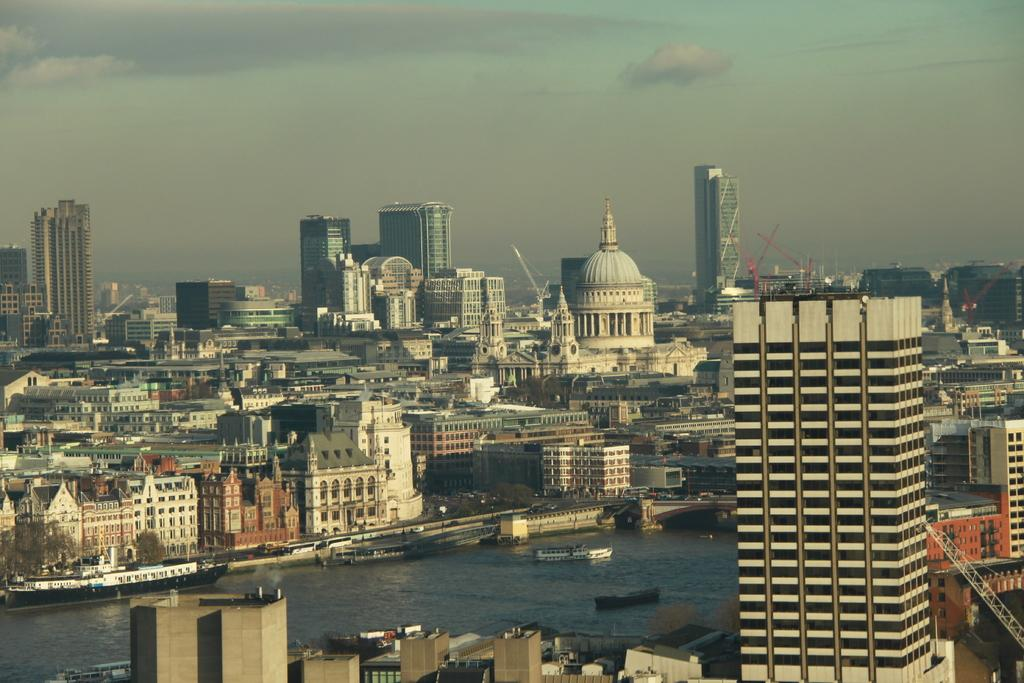What type of structures can be seen in the image? There are buildings in the image. What construction equipment is visible in the image? There are cranes in the image. What type of vehicles are present in the water in the image? There are ships in the water in the image. What type of transportation infrastructure is present in the image? There is a bridge in the image. What type of vehicles are on the road in the image? There are vehicles on the road in the image. What can be seen in the sky in the image? There are clouds in the sky in the image. Can you tell me how many times the grandmother swims across the river in the image? There is no grandmother or river present in the image. What word is written on the side of the building in the image? There is no word visible on the buildings in the image. 